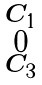Convert formula to latex. <formula><loc_0><loc_0><loc_500><loc_500>\begin{smallmatrix} C _ { 1 } \\ 0 \\ C _ { 3 } \end{smallmatrix}</formula> 